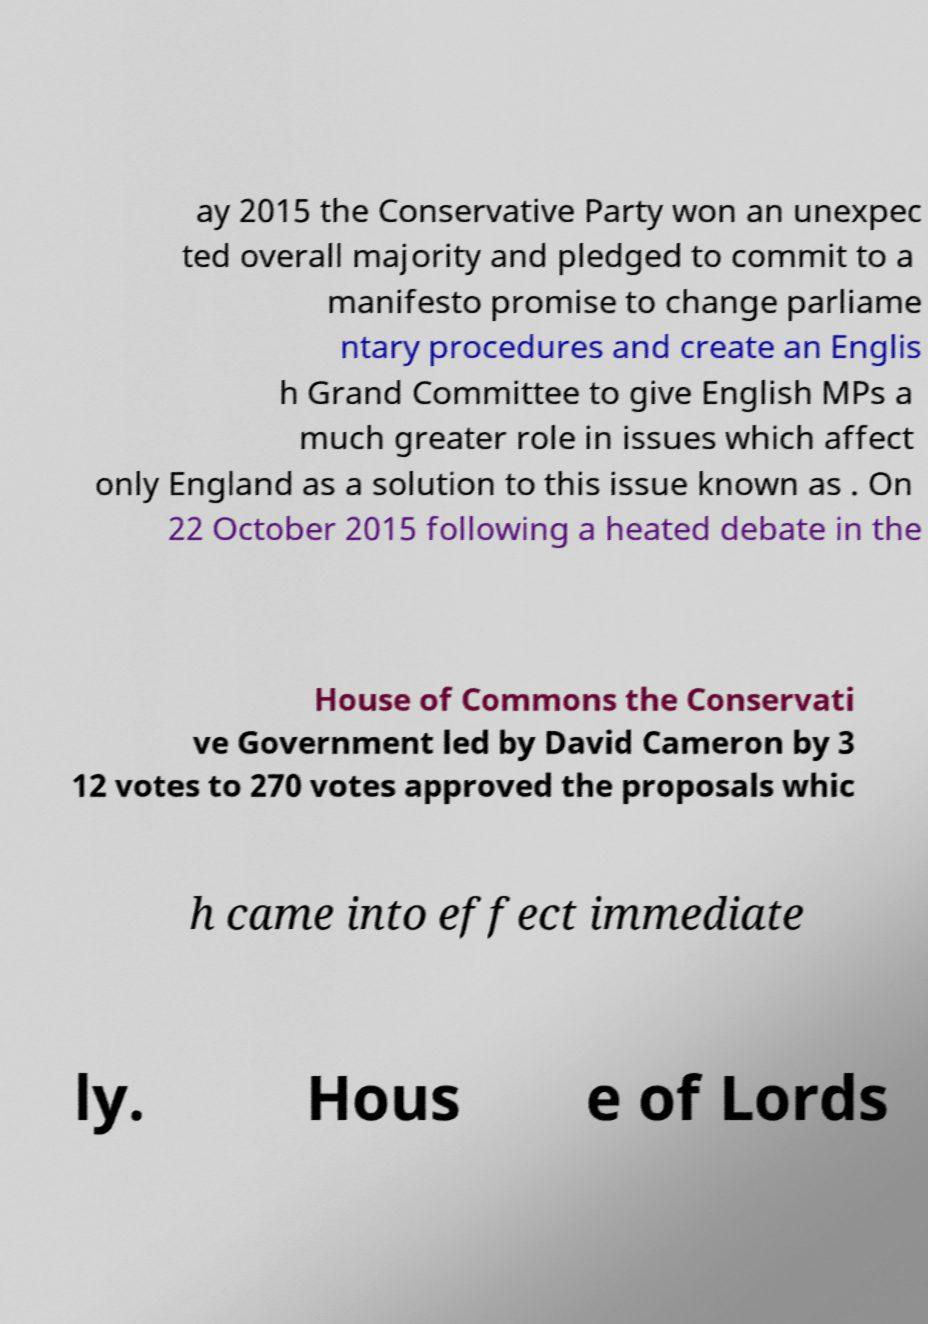What messages or text are displayed in this image? I need them in a readable, typed format. ay 2015 the Conservative Party won an unexpec ted overall majority and pledged to commit to a manifesto promise to change parliame ntary procedures and create an Englis h Grand Committee to give English MPs a much greater role in issues which affect only England as a solution to this issue known as . On 22 October 2015 following a heated debate in the House of Commons the Conservati ve Government led by David Cameron by 3 12 votes to 270 votes approved the proposals whic h came into effect immediate ly. Hous e of Lords 